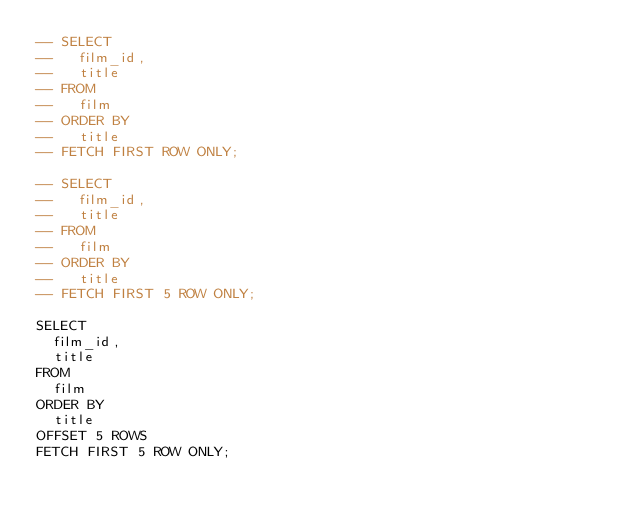Convert code to text. <code><loc_0><loc_0><loc_500><loc_500><_SQL_>-- SELECT
--   film_id,
--   title
-- FROM
--   film
-- ORDER BY
--   title
-- FETCH FIRST ROW ONLY;

-- SELECT
--   film_id,
--   title
-- FROM
--   film
-- ORDER BY
--   title
-- FETCH FIRST 5 ROW ONLY;

SELECT
  film_id,
  title
FROM
  film
ORDER BY
  title
OFFSET 5 ROWS
FETCH FIRST 5 ROW ONLY;

</code> 